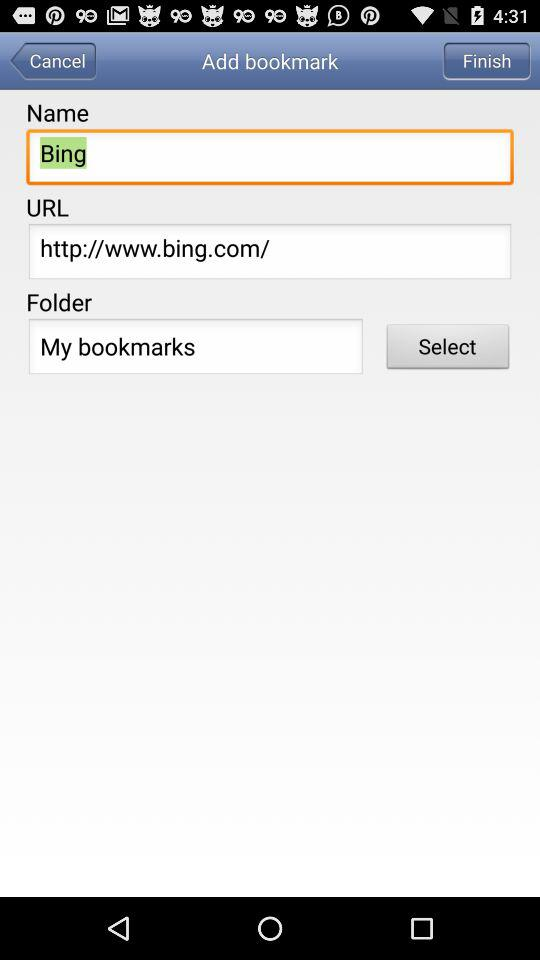What is given URL? The given URL is "http://www.bing.com/". 